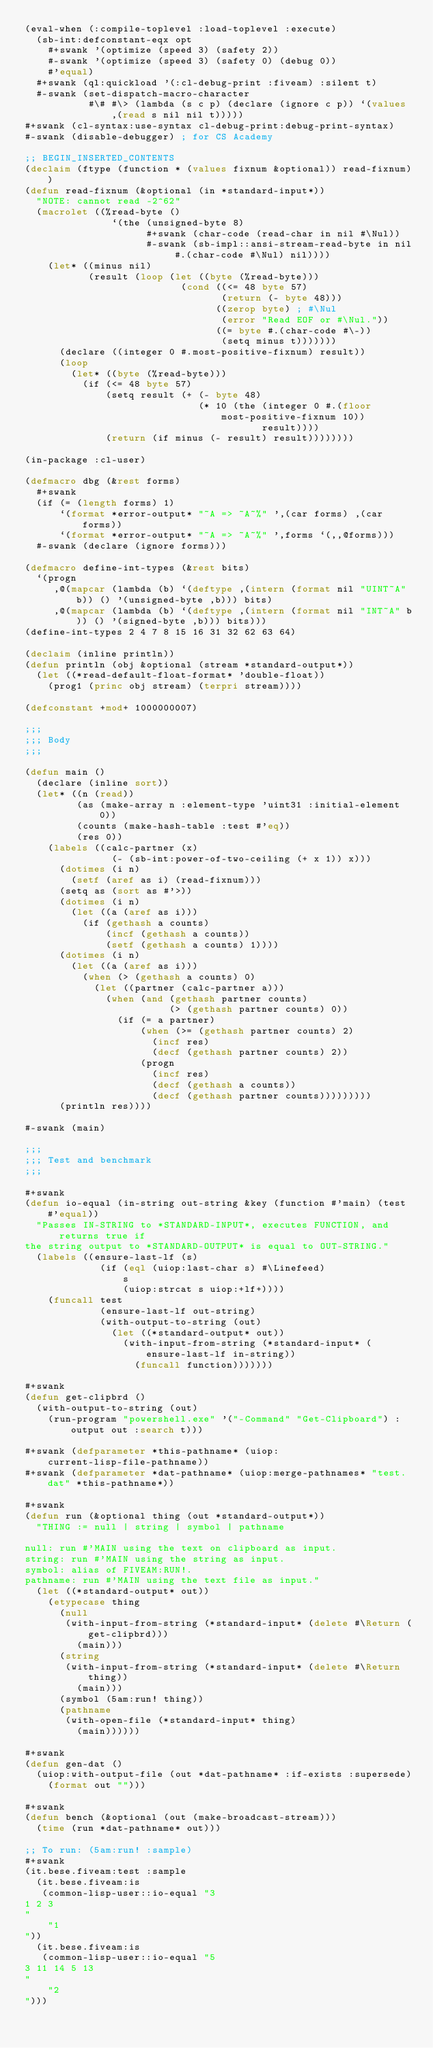<code> <loc_0><loc_0><loc_500><loc_500><_Lisp_>(eval-when (:compile-toplevel :load-toplevel :execute)
  (sb-int:defconstant-eqx opt
    #+swank '(optimize (speed 3) (safety 2))
    #-swank '(optimize (speed 3) (safety 0) (debug 0))
    #'equal)
  #+swank (ql:quickload '(:cl-debug-print :fiveam) :silent t)
  #-swank (set-dispatch-macro-character
           #\# #\> (lambda (s c p) (declare (ignore c p)) `(values ,(read s nil nil t)))))
#+swank (cl-syntax:use-syntax cl-debug-print:debug-print-syntax)
#-swank (disable-debugger) ; for CS Academy

;; BEGIN_INSERTED_CONTENTS
(declaim (ftype (function * (values fixnum &optional)) read-fixnum))
(defun read-fixnum (&optional (in *standard-input*))
  "NOTE: cannot read -2^62"
  (macrolet ((%read-byte ()
               `(the (unsigned-byte 8)
                     #+swank (char-code (read-char in nil #\Nul))
                     #-swank (sb-impl::ansi-stream-read-byte in nil #.(char-code #\Nul) nil))))
    (let* ((minus nil)
           (result (loop (let ((byte (%read-byte)))
                           (cond ((<= 48 byte 57)
                                  (return (- byte 48)))
                                 ((zerop byte) ; #\Nul
                                  (error "Read EOF or #\Nul."))
                                 ((= byte #.(char-code #\-))
                                  (setq minus t)))))))
      (declare ((integer 0 #.most-positive-fixnum) result))
      (loop
        (let* ((byte (%read-byte)))
          (if (<= 48 byte 57)
              (setq result (+ (- byte 48)
                              (* 10 (the (integer 0 #.(floor most-positive-fixnum 10))
                                         result))))
              (return (if minus (- result) result))))))))

(in-package :cl-user)

(defmacro dbg (&rest forms)
  #+swank
  (if (= (length forms) 1)
      `(format *error-output* "~A => ~A~%" ',(car forms) ,(car forms))
      `(format *error-output* "~A => ~A~%" ',forms `(,,@forms)))
  #-swank (declare (ignore forms)))

(defmacro define-int-types (&rest bits)
  `(progn
     ,@(mapcar (lambda (b) `(deftype ,(intern (format nil "UINT~A" b)) () '(unsigned-byte ,b))) bits)
     ,@(mapcar (lambda (b) `(deftype ,(intern (format nil "INT~A" b)) () '(signed-byte ,b))) bits)))
(define-int-types 2 4 7 8 15 16 31 32 62 63 64)

(declaim (inline println))
(defun println (obj &optional (stream *standard-output*))
  (let ((*read-default-float-format* 'double-float))
    (prog1 (princ obj stream) (terpri stream))))

(defconstant +mod+ 1000000007)

;;;
;;; Body
;;;

(defun main ()
  (declare (inline sort))
  (let* ((n (read))
         (as (make-array n :element-type 'uint31 :initial-element 0))
         (counts (make-hash-table :test #'eq))
         (res 0))
    (labels ((calc-partner (x)
               (- (sb-int:power-of-two-ceiling (+ x 1)) x)))
      (dotimes (i n)
        (setf (aref as i) (read-fixnum)))
      (setq as (sort as #'>))
      (dotimes (i n)
        (let ((a (aref as i)))
          (if (gethash a counts)
              (incf (gethash a counts))
              (setf (gethash a counts) 1))))
      (dotimes (i n)
        (let ((a (aref as i)))
          (when (> (gethash a counts) 0)
            (let ((partner (calc-partner a)))
              (when (and (gethash partner counts)
                         (> (gethash partner counts) 0))
                (if (= a partner)
                    (when (>= (gethash partner counts) 2)
                      (incf res)
                      (decf (gethash partner counts) 2))
                    (progn
                      (incf res)
                      (decf (gethash a counts))
                      (decf (gethash partner counts)))))))))
      (println res))))

#-swank (main)

;;;
;;; Test and benchmark
;;;

#+swank
(defun io-equal (in-string out-string &key (function #'main) (test #'equal))
  "Passes IN-STRING to *STANDARD-INPUT*, executes FUNCTION, and returns true if
the string output to *STANDARD-OUTPUT* is equal to OUT-STRING."
  (labels ((ensure-last-lf (s)
             (if (eql (uiop:last-char s) #\Linefeed)
                 s
                 (uiop:strcat s uiop:+lf+))))
    (funcall test
             (ensure-last-lf out-string)
             (with-output-to-string (out)
               (let ((*standard-output* out))
                 (with-input-from-string (*standard-input* (ensure-last-lf in-string))
                   (funcall function)))))))

#+swank
(defun get-clipbrd ()
  (with-output-to-string (out)
    (run-program "powershell.exe" '("-Command" "Get-Clipboard") :output out :search t)))

#+swank (defparameter *this-pathname* (uiop:current-lisp-file-pathname))
#+swank (defparameter *dat-pathname* (uiop:merge-pathnames* "test.dat" *this-pathname*))

#+swank
(defun run (&optional thing (out *standard-output*))
  "THING := null | string | symbol | pathname

null: run #'MAIN using the text on clipboard as input.
string: run #'MAIN using the string as input.
symbol: alias of FIVEAM:RUN!.
pathname: run #'MAIN using the text file as input."
  (let ((*standard-output* out))
    (etypecase thing
      (null
       (with-input-from-string (*standard-input* (delete #\Return (get-clipbrd)))
         (main)))
      (string
       (with-input-from-string (*standard-input* (delete #\Return thing))
         (main)))
      (symbol (5am:run! thing))
      (pathname
       (with-open-file (*standard-input* thing)
         (main))))))

#+swank
(defun gen-dat ()
  (uiop:with-output-file (out *dat-pathname* :if-exists :supersede)
    (format out "")))

#+swank
(defun bench (&optional (out (make-broadcast-stream)))
  (time (run *dat-pathname* out)))

;; To run: (5am:run! :sample)
#+swank
(it.bese.fiveam:test :sample
  (it.bese.fiveam:is
   (common-lisp-user::io-equal "3
1 2 3
"
    "1
"))
  (it.bese.fiveam:is
   (common-lisp-user::io-equal "5
3 11 14 5 13
"
    "2
")))
</code> 